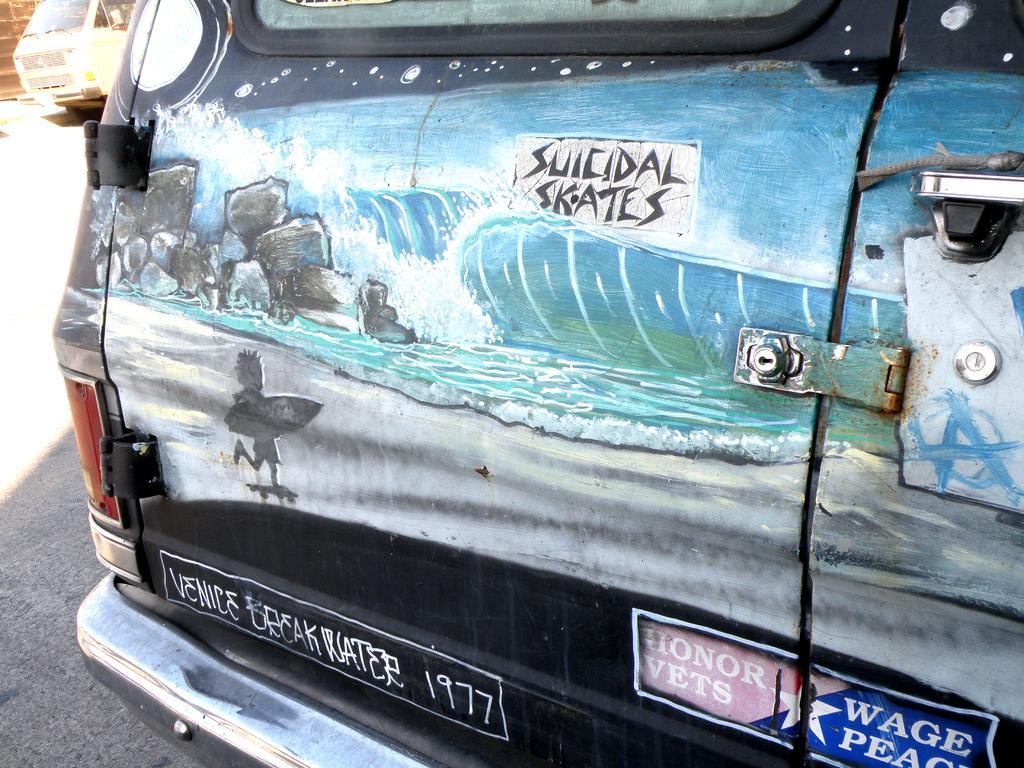Please provide a concise description of this image. In this image there is a vehicle parked, in the background there is a vehicle and a wall. 